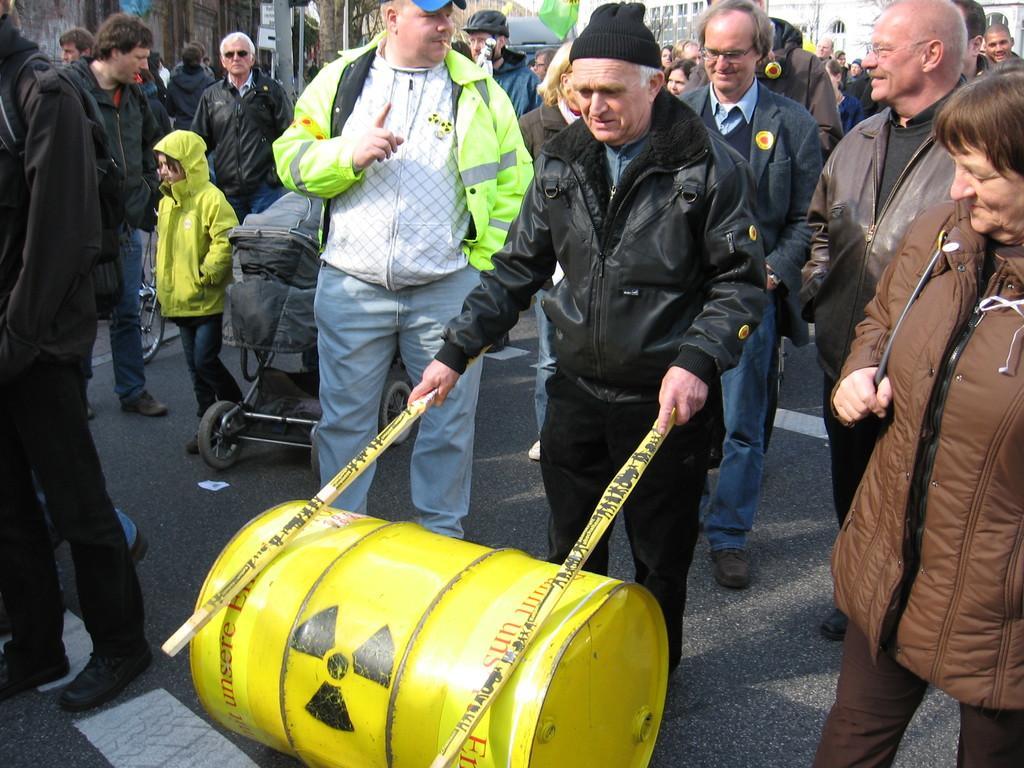In one or two sentences, can you explain what this image depicts? There is a group of persons standing in the middle of this image. The person standing in the middle is wearing a black color jacket and holding two sticks. There is a bag trolley on the left side of this image and there is a yellow color drum at the bottom of this image. 